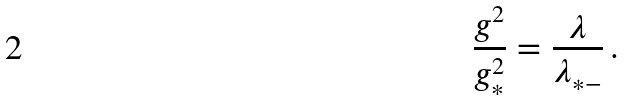<formula> <loc_0><loc_0><loc_500><loc_500>\frac { g ^ { 2 } } { g _ { * } ^ { 2 } } = \frac { \lambda } { \lambda _ { * - } } \, .</formula> 